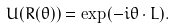Convert formula to latex. <formula><loc_0><loc_0><loc_500><loc_500>U ( R ( \theta ) ) = \exp ( - i \theta \cdot L ) .</formula> 